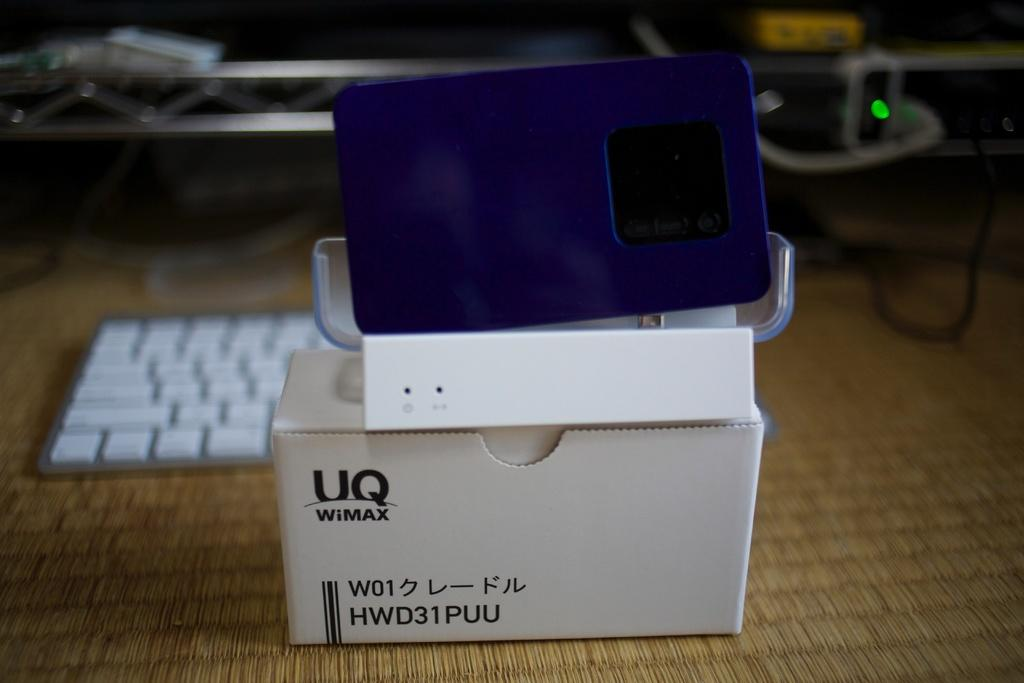What object is present in the image? There is a box in the image. What can be seen on the box? There is a device in blue color on the box. What is visible in the background of the image? There is a keyboard in the background of the image. How would you describe the background of the image? The background is blurred. Can you see a snail crawling on the keyboard in the image? There is no snail present in the image; only the box, the device on the box, and the keyboard are visible. Is there a hose connected to the device on the box? There is no hose connected to the device on the box in the image. 